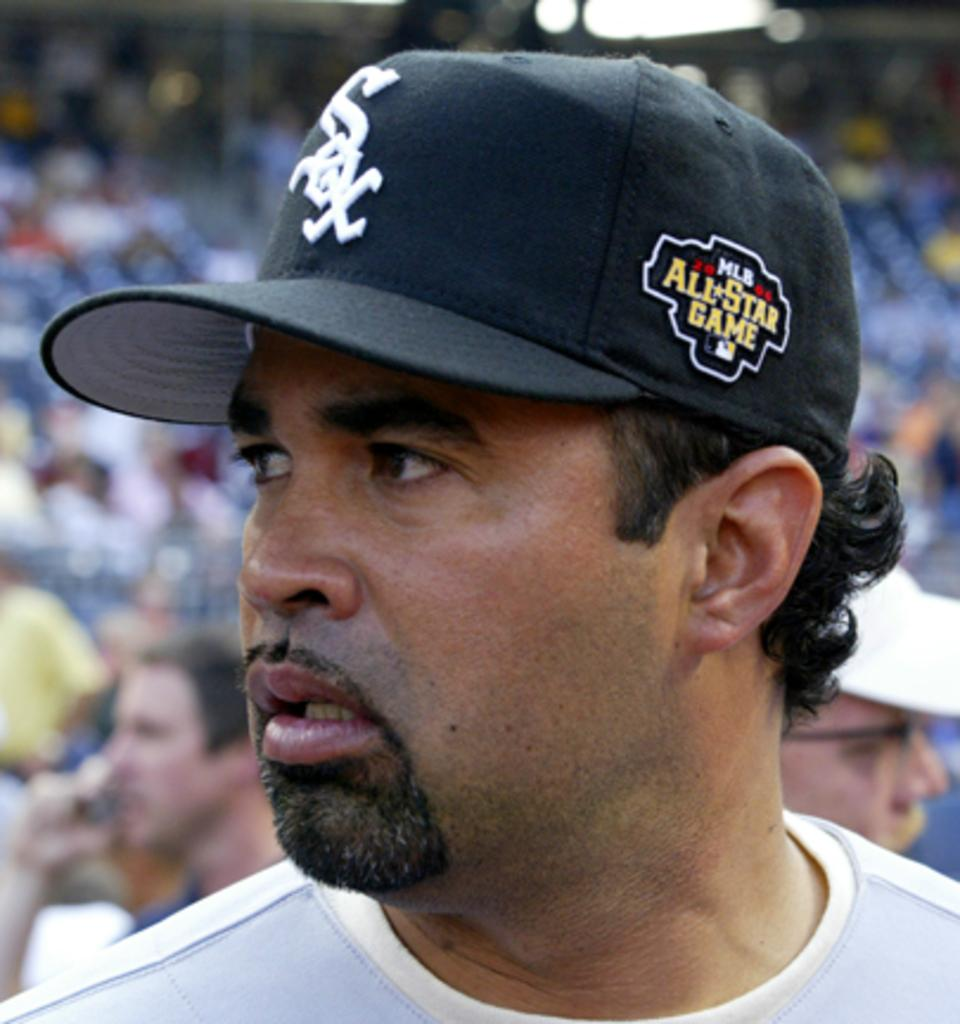<image>
Summarize the visual content of the image. A hispanic wearing an All Star game sox baseball player looking to the right. 